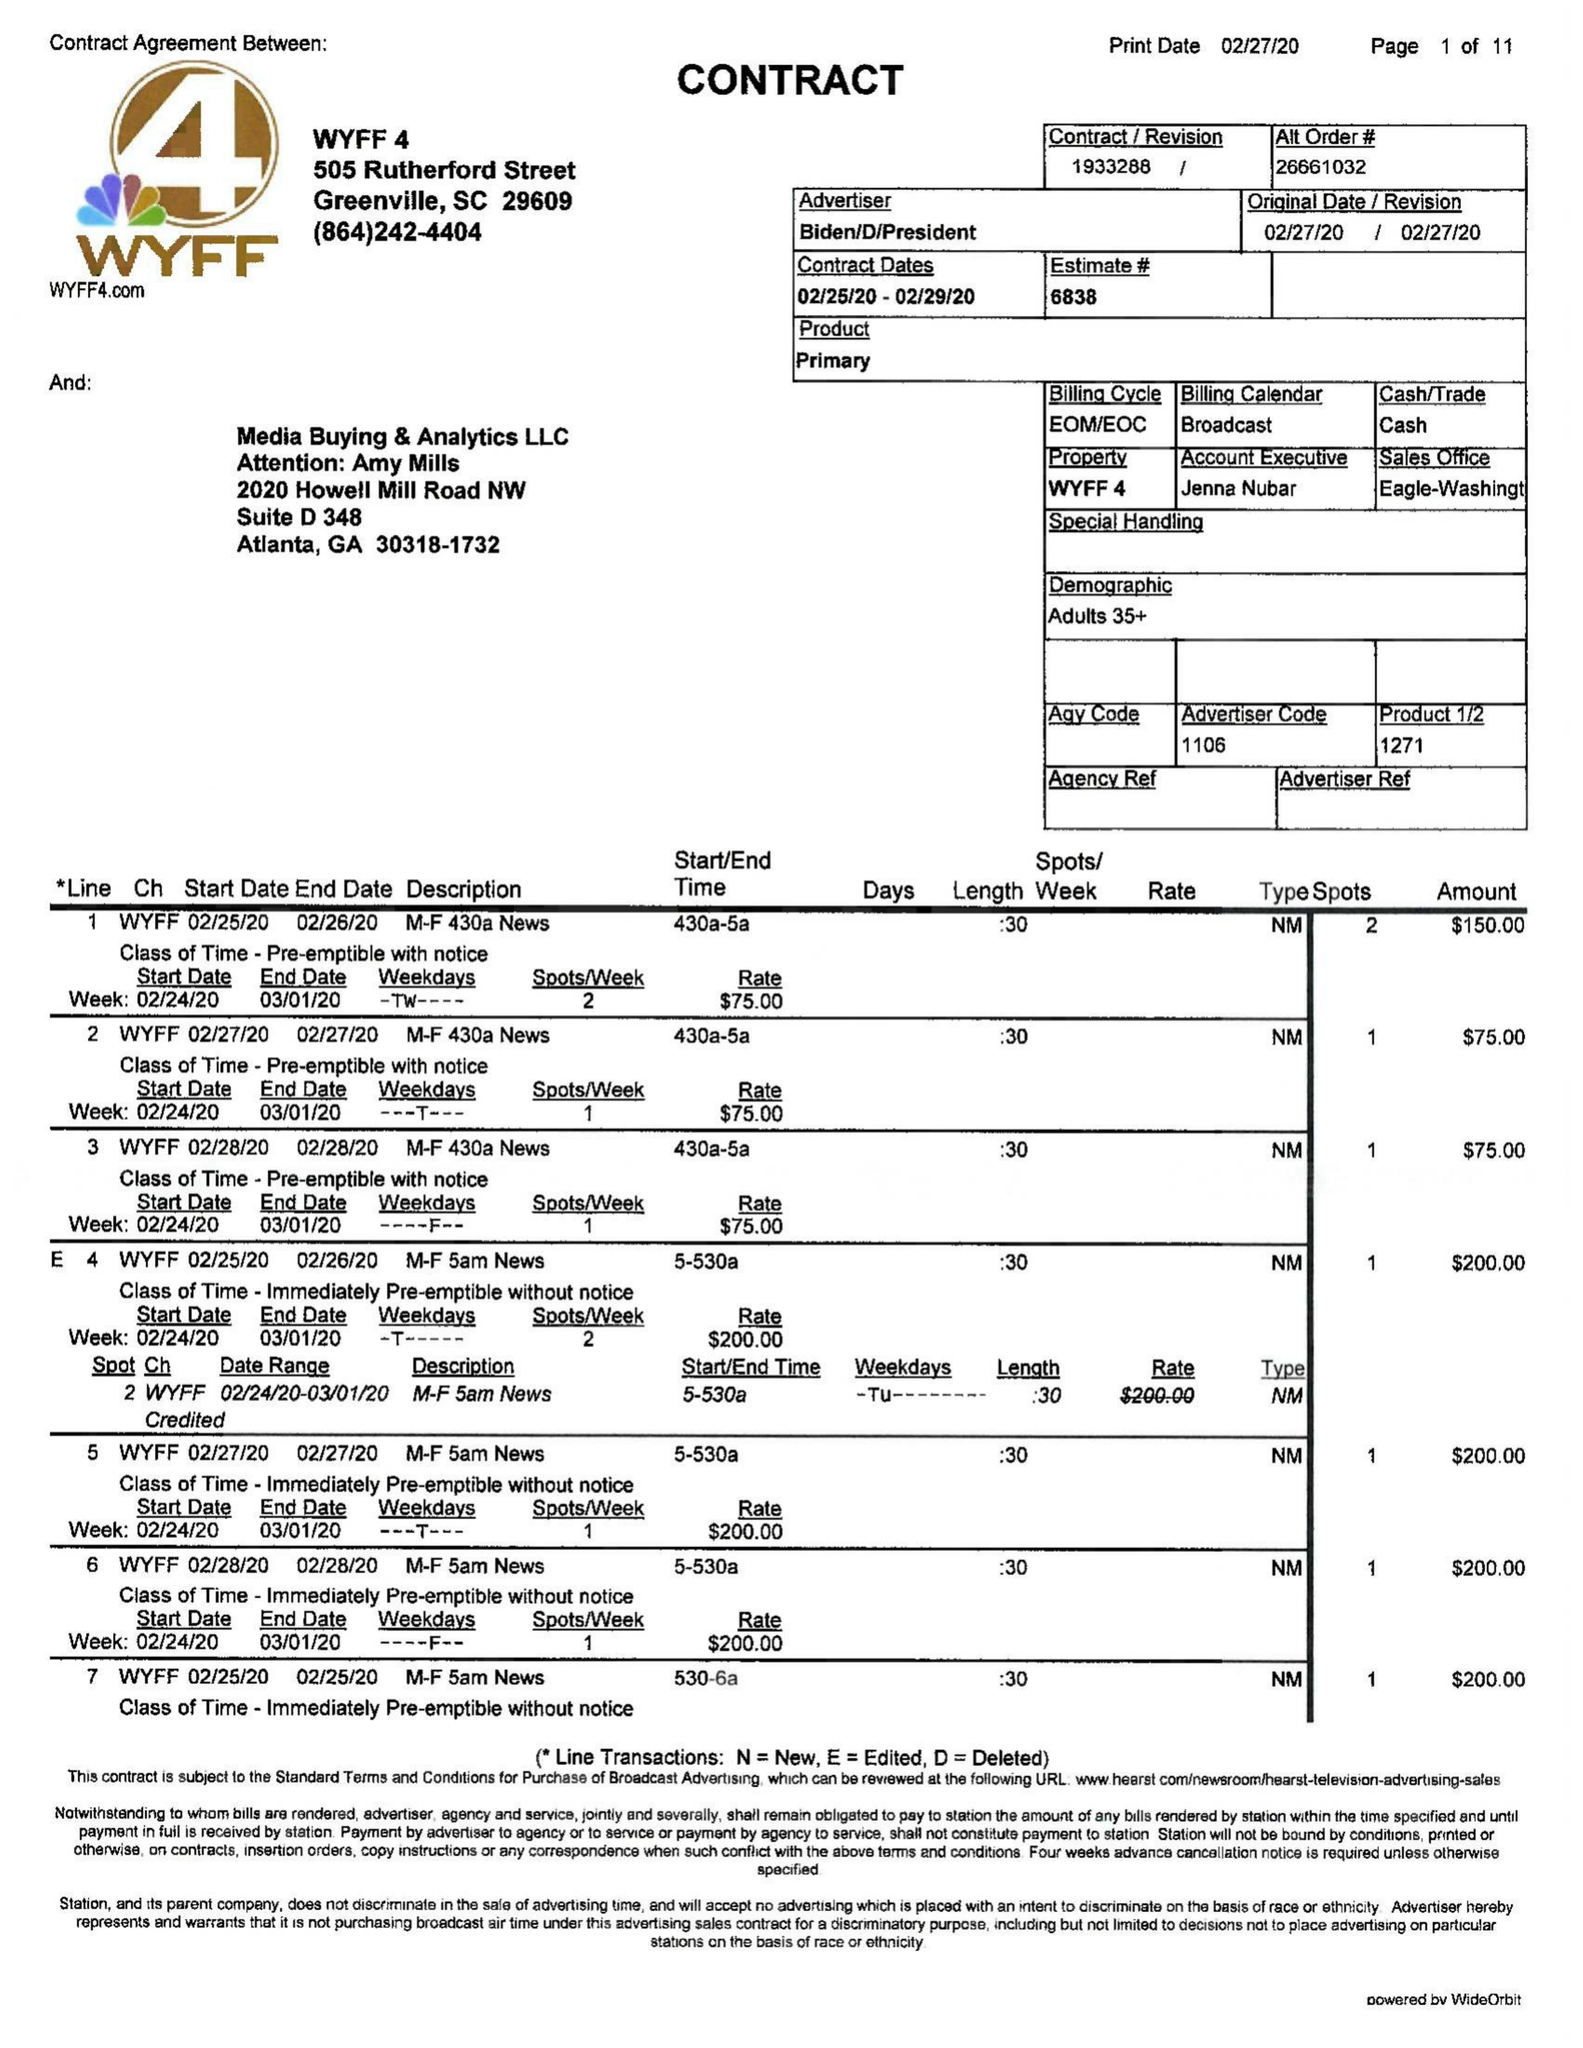What is the value for the advertiser?
Answer the question using a single word or phrase. BIDEN/D/PRESIDENT 